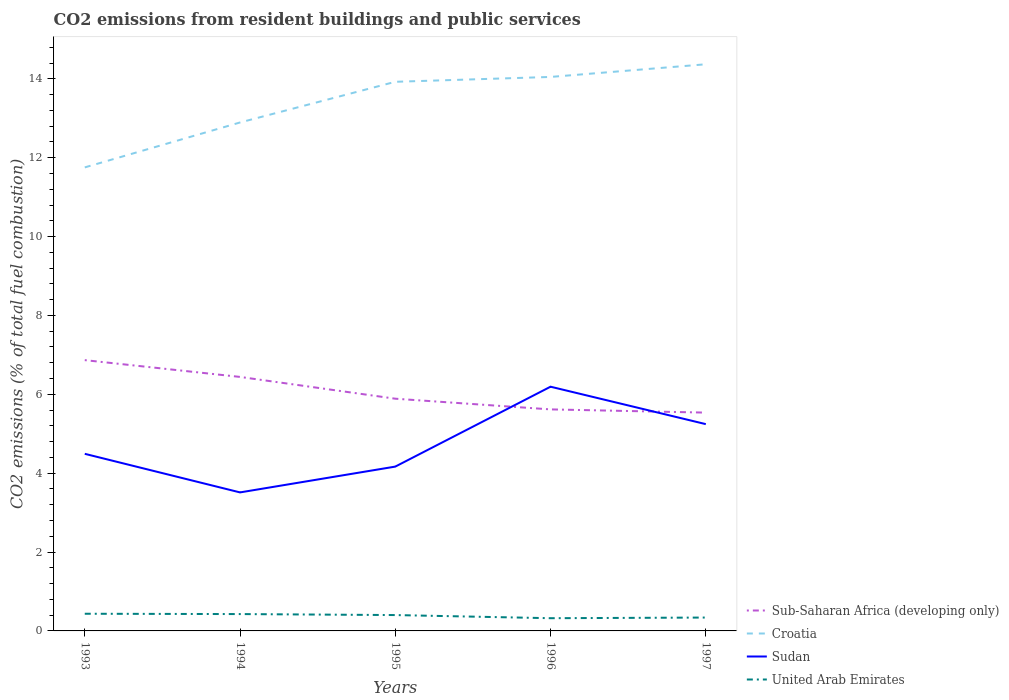How many different coloured lines are there?
Your answer should be compact. 4. Is the number of lines equal to the number of legend labels?
Provide a short and direct response. Yes. Across all years, what is the maximum total CO2 emitted in Sub-Saharan Africa (developing only)?
Ensure brevity in your answer.  5.54. What is the total total CO2 emitted in Sudan in the graph?
Make the answer very short. -0.75. What is the difference between the highest and the second highest total CO2 emitted in United Arab Emirates?
Keep it short and to the point. 0.11. How many lines are there?
Make the answer very short. 4. How many years are there in the graph?
Provide a succinct answer. 5. Are the values on the major ticks of Y-axis written in scientific E-notation?
Your response must be concise. No. Does the graph contain any zero values?
Your answer should be compact. No. Does the graph contain grids?
Offer a terse response. No. How many legend labels are there?
Your answer should be compact. 4. What is the title of the graph?
Provide a short and direct response. CO2 emissions from resident buildings and public services. What is the label or title of the Y-axis?
Offer a terse response. CO2 emissions (% of total fuel combustion). What is the CO2 emissions (% of total fuel combustion) of Sub-Saharan Africa (developing only) in 1993?
Provide a succinct answer. 6.87. What is the CO2 emissions (% of total fuel combustion) in Croatia in 1993?
Offer a very short reply. 11.75. What is the CO2 emissions (% of total fuel combustion) of Sudan in 1993?
Give a very brief answer. 4.49. What is the CO2 emissions (% of total fuel combustion) in United Arab Emirates in 1993?
Your answer should be very brief. 0.44. What is the CO2 emissions (% of total fuel combustion) in Sub-Saharan Africa (developing only) in 1994?
Provide a succinct answer. 6.44. What is the CO2 emissions (% of total fuel combustion) of Croatia in 1994?
Provide a short and direct response. 12.89. What is the CO2 emissions (% of total fuel combustion) in Sudan in 1994?
Offer a very short reply. 3.51. What is the CO2 emissions (% of total fuel combustion) in United Arab Emirates in 1994?
Offer a very short reply. 0.43. What is the CO2 emissions (% of total fuel combustion) in Sub-Saharan Africa (developing only) in 1995?
Your answer should be compact. 5.89. What is the CO2 emissions (% of total fuel combustion) in Croatia in 1995?
Your answer should be compact. 13.92. What is the CO2 emissions (% of total fuel combustion) of Sudan in 1995?
Provide a short and direct response. 4.17. What is the CO2 emissions (% of total fuel combustion) of United Arab Emirates in 1995?
Your answer should be very brief. 0.4. What is the CO2 emissions (% of total fuel combustion) in Sub-Saharan Africa (developing only) in 1996?
Your answer should be compact. 5.62. What is the CO2 emissions (% of total fuel combustion) of Croatia in 1996?
Give a very brief answer. 14.05. What is the CO2 emissions (% of total fuel combustion) of Sudan in 1996?
Your answer should be compact. 6.19. What is the CO2 emissions (% of total fuel combustion) of United Arab Emirates in 1996?
Keep it short and to the point. 0.32. What is the CO2 emissions (% of total fuel combustion) in Sub-Saharan Africa (developing only) in 1997?
Make the answer very short. 5.54. What is the CO2 emissions (% of total fuel combustion) of Croatia in 1997?
Ensure brevity in your answer.  14.37. What is the CO2 emissions (% of total fuel combustion) in Sudan in 1997?
Give a very brief answer. 5.24. What is the CO2 emissions (% of total fuel combustion) in United Arab Emirates in 1997?
Keep it short and to the point. 0.34. Across all years, what is the maximum CO2 emissions (% of total fuel combustion) of Sub-Saharan Africa (developing only)?
Ensure brevity in your answer.  6.87. Across all years, what is the maximum CO2 emissions (% of total fuel combustion) of Croatia?
Provide a succinct answer. 14.37. Across all years, what is the maximum CO2 emissions (% of total fuel combustion) in Sudan?
Ensure brevity in your answer.  6.19. Across all years, what is the maximum CO2 emissions (% of total fuel combustion) of United Arab Emirates?
Make the answer very short. 0.44. Across all years, what is the minimum CO2 emissions (% of total fuel combustion) in Sub-Saharan Africa (developing only)?
Provide a succinct answer. 5.54. Across all years, what is the minimum CO2 emissions (% of total fuel combustion) in Croatia?
Offer a very short reply. 11.75. Across all years, what is the minimum CO2 emissions (% of total fuel combustion) in Sudan?
Keep it short and to the point. 3.51. Across all years, what is the minimum CO2 emissions (% of total fuel combustion) in United Arab Emirates?
Keep it short and to the point. 0.32. What is the total CO2 emissions (% of total fuel combustion) in Sub-Saharan Africa (developing only) in the graph?
Provide a succinct answer. 30.35. What is the total CO2 emissions (% of total fuel combustion) of Croatia in the graph?
Offer a terse response. 66.99. What is the total CO2 emissions (% of total fuel combustion) of Sudan in the graph?
Provide a succinct answer. 23.61. What is the total CO2 emissions (% of total fuel combustion) of United Arab Emirates in the graph?
Your answer should be very brief. 1.93. What is the difference between the CO2 emissions (% of total fuel combustion) in Sub-Saharan Africa (developing only) in 1993 and that in 1994?
Your answer should be compact. 0.43. What is the difference between the CO2 emissions (% of total fuel combustion) of Croatia in 1993 and that in 1994?
Your answer should be very brief. -1.14. What is the difference between the CO2 emissions (% of total fuel combustion) in Sudan in 1993 and that in 1994?
Offer a terse response. 0.98. What is the difference between the CO2 emissions (% of total fuel combustion) in United Arab Emirates in 1993 and that in 1994?
Give a very brief answer. 0.01. What is the difference between the CO2 emissions (% of total fuel combustion) of Sub-Saharan Africa (developing only) in 1993 and that in 1995?
Provide a short and direct response. 0.98. What is the difference between the CO2 emissions (% of total fuel combustion) in Croatia in 1993 and that in 1995?
Ensure brevity in your answer.  -2.17. What is the difference between the CO2 emissions (% of total fuel combustion) in Sudan in 1993 and that in 1995?
Your response must be concise. 0.32. What is the difference between the CO2 emissions (% of total fuel combustion) of United Arab Emirates in 1993 and that in 1995?
Your response must be concise. 0.03. What is the difference between the CO2 emissions (% of total fuel combustion) in Sub-Saharan Africa (developing only) in 1993 and that in 1996?
Your response must be concise. 1.25. What is the difference between the CO2 emissions (% of total fuel combustion) in Croatia in 1993 and that in 1996?
Give a very brief answer. -2.29. What is the difference between the CO2 emissions (% of total fuel combustion) of Sudan in 1993 and that in 1996?
Your answer should be very brief. -1.7. What is the difference between the CO2 emissions (% of total fuel combustion) in United Arab Emirates in 1993 and that in 1996?
Make the answer very short. 0.11. What is the difference between the CO2 emissions (% of total fuel combustion) of Sub-Saharan Africa (developing only) in 1993 and that in 1997?
Make the answer very short. 1.33. What is the difference between the CO2 emissions (% of total fuel combustion) in Croatia in 1993 and that in 1997?
Provide a succinct answer. -2.62. What is the difference between the CO2 emissions (% of total fuel combustion) in Sudan in 1993 and that in 1997?
Give a very brief answer. -0.75. What is the difference between the CO2 emissions (% of total fuel combustion) in United Arab Emirates in 1993 and that in 1997?
Your answer should be very brief. 0.1. What is the difference between the CO2 emissions (% of total fuel combustion) in Sub-Saharan Africa (developing only) in 1994 and that in 1995?
Give a very brief answer. 0.55. What is the difference between the CO2 emissions (% of total fuel combustion) of Croatia in 1994 and that in 1995?
Give a very brief answer. -1.03. What is the difference between the CO2 emissions (% of total fuel combustion) in Sudan in 1994 and that in 1995?
Make the answer very short. -0.65. What is the difference between the CO2 emissions (% of total fuel combustion) in United Arab Emirates in 1994 and that in 1995?
Make the answer very short. 0.03. What is the difference between the CO2 emissions (% of total fuel combustion) of Sub-Saharan Africa (developing only) in 1994 and that in 1996?
Provide a succinct answer. 0.82. What is the difference between the CO2 emissions (% of total fuel combustion) of Croatia in 1994 and that in 1996?
Your answer should be very brief. -1.16. What is the difference between the CO2 emissions (% of total fuel combustion) in Sudan in 1994 and that in 1996?
Provide a short and direct response. -2.68. What is the difference between the CO2 emissions (% of total fuel combustion) of United Arab Emirates in 1994 and that in 1996?
Provide a succinct answer. 0.1. What is the difference between the CO2 emissions (% of total fuel combustion) in Sub-Saharan Africa (developing only) in 1994 and that in 1997?
Your answer should be compact. 0.91. What is the difference between the CO2 emissions (% of total fuel combustion) of Croatia in 1994 and that in 1997?
Your answer should be compact. -1.48. What is the difference between the CO2 emissions (% of total fuel combustion) in Sudan in 1994 and that in 1997?
Your response must be concise. -1.73. What is the difference between the CO2 emissions (% of total fuel combustion) in United Arab Emirates in 1994 and that in 1997?
Your answer should be very brief. 0.09. What is the difference between the CO2 emissions (% of total fuel combustion) in Sub-Saharan Africa (developing only) in 1995 and that in 1996?
Keep it short and to the point. 0.27. What is the difference between the CO2 emissions (% of total fuel combustion) of Croatia in 1995 and that in 1996?
Your answer should be very brief. -0.12. What is the difference between the CO2 emissions (% of total fuel combustion) in Sudan in 1995 and that in 1996?
Your response must be concise. -2.03. What is the difference between the CO2 emissions (% of total fuel combustion) in United Arab Emirates in 1995 and that in 1996?
Provide a short and direct response. 0.08. What is the difference between the CO2 emissions (% of total fuel combustion) in Sub-Saharan Africa (developing only) in 1995 and that in 1997?
Offer a terse response. 0.35. What is the difference between the CO2 emissions (% of total fuel combustion) in Croatia in 1995 and that in 1997?
Provide a short and direct response. -0.44. What is the difference between the CO2 emissions (% of total fuel combustion) of Sudan in 1995 and that in 1997?
Your answer should be compact. -1.08. What is the difference between the CO2 emissions (% of total fuel combustion) of United Arab Emirates in 1995 and that in 1997?
Your answer should be compact. 0.06. What is the difference between the CO2 emissions (% of total fuel combustion) of Sub-Saharan Africa (developing only) in 1996 and that in 1997?
Your response must be concise. 0.08. What is the difference between the CO2 emissions (% of total fuel combustion) in Croatia in 1996 and that in 1997?
Offer a terse response. -0.32. What is the difference between the CO2 emissions (% of total fuel combustion) of Sudan in 1996 and that in 1997?
Give a very brief answer. 0.95. What is the difference between the CO2 emissions (% of total fuel combustion) of United Arab Emirates in 1996 and that in 1997?
Give a very brief answer. -0.02. What is the difference between the CO2 emissions (% of total fuel combustion) in Sub-Saharan Africa (developing only) in 1993 and the CO2 emissions (% of total fuel combustion) in Croatia in 1994?
Provide a succinct answer. -6.03. What is the difference between the CO2 emissions (% of total fuel combustion) of Sub-Saharan Africa (developing only) in 1993 and the CO2 emissions (% of total fuel combustion) of Sudan in 1994?
Make the answer very short. 3.35. What is the difference between the CO2 emissions (% of total fuel combustion) in Sub-Saharan Africa (developing only) in 1993 and the CO2 emissions (% of total fuel combustion) in United Arab Emirates in 1994?
Ensure brevity in your answer.  6.44. What is the difference between the CO2 emissions (% of total fuel combustion) of Croatia in 1993 and the CO2 emissions (% of total fuel combustion) of Sudan in 1994?
Your answer should be very brief. 8.24. What is the difference between the CO2 emissions (% of total fuel combustion) of Croatia in 1993 and the CO2 emissions (% of total fuel combustion) of United Arab Emirates in 1994?
Provide a short and direct response. 11.33. What is the difference between the CO2 emissions (% of total fuel combustion) in Sudan in 1993 and the CO2 emissions (% of total fuel combustion) in United Arab Emirates in 1994?
Keep it short and to the point. 4.06. What is the difference between the CO2 emissions (% of total fuel combustion) in Sub-Saharan Africa (developing only) in 1993 and the CO2 emissions (% of total fuel combustion) in Croatia in 1995?
Give a very brief answer. -7.06. What is the difference between the CO2 emissions (% of total fuel combustion) in Sub-Saharan Africa (developing only) in 1993 and the CO2 emissions (% of total fuel combustion) in Sudan in 1995?
Offer a very short reply. 2.7. What is the difference between the CO2 emissions (% of total fuel combustion) in Sub-Saharan Africa (developing only) in 1993 and the CO2 emissions (% of total fuel combustion) in United Arab Emirates in 1995?
Make the answer very short. 6.46. What is the difference between the CO2 emissions (% of total fuel combustion) of Croatia in 1993 and the CO2 emissions (% of total fuel combustion) of Sudan in 1995?
Your response must be concise. 7.59. What is the difference between the CO2 emissions (% of total fuel combustion) in Croatia in 1993 and the CO2 emissions (% of total fuel combustion) in United Arab Emirates in 1995?
Offer a very short reply. 11.35. What is the difference between the CO2 emissions (% of total fuel combustion) of Sudan in 1993 and the CO2 emissions (% of total fuel combustion) of United Arab Emirates in 1995?
Offer a terse response. 4.09. What is the difference between the CO2 emissions (% of total fuel combustion) in Sub-Saharan Africa (developing only) in 1993 and the CO2 emissions (% of total fuel combustion) in Croatia in 1996?
Your response must be concise. -7.18. What is the difference between the CO2 emissions (% of total fuel combustion) in Sub-Saharan Africa (developing only) in 1993 and the CO2 emissions (% of total fuel combustion) in Sudan in 1996?
Keep it short and to the point. 0.67. What is the difference between the CO2 emissions (% of total fuel combustion) in Sub-Saharan Africa (developing only) in 1993 and the CO2 emissions (% of total fuel combustion) in United Arab Emirates in 1996?
Your answer should be very brief. 6.54. What is the difference between the CO2 emissions (% of total fuel combustion) of Croatia in 1993 and the CO2 emissions (% of total fuel combustion) of Sudan in 1996?
Your answer should be compact. 5.56. What is the difference between the CO2 emissions (% of total fuel combustion) in Croatia in 1993 and the CO2 emissions (% of total fuel combustion) in United Arab Emirates in 1996?
Provide a short and direct response. 11.43. What is the difference between the CO2 emissions (% of total fuel combustion) of Sudan in 1993 and the CO2 emissions (% of total fuel combustion) of United Arab Emirates in 1996?
Ensure brevity in your answer.  4.17. What is the difference between the CO2 emissions (% of total fuel combustion) in Sub-Saharan Africa (developing only) in 1993 and the CO2 emissions (% of total fuel combustion) in Croatia in 1997?
Provide a short and direct response. -7.5. What is the difference between the CO2 emissions (% of total fuel combustion) in Sub-Saharan Africa (developing only) in 1993 and the CO2 emissions (% of total fuel combustion) in Sudan in 1997?
Provide a short and direct response. 1.62. What is the difference between the CO2 emissions (% of total fuel combustion) of Sub-Saharan Africa (developing only) in 1993 and the CO2 emissions (% of total fuel combustion) of United Arab Emirates in 1997?
Your answer should be compact. 6.53. What is the difference between the CO2 emissions (% of total fuel combustion) of Croatia in 1993 and the CO2 emissions (% of total fuel combustion) of Sudan in 1997?
Provide a short and direct response. 6.51. What is the difference between the CO2 emissions (% of total fuel combustion) of Croatia in 1993 and the CO2 emissions (% of total fuel combustion) of United Arab Emirates in 1997?
Provide a succinct answer. 11.41. What is the difference between the CO2 emissions (% of total fuel combustion) in Sudan in 1993 and the CO2 emissions (% of total fuel combustion) in United Arab Emirates in 1997?
Your answer should be very brief. 4.15. What is the difference between the CO2 emissions (% of total fuel combustion) of Sub-Saharan Africa (developing only) in 1994 and the CO2 emissions (% of total fuel combustion) of Croatia in 1995?
Offer a very short reply. -7.48. What is the difference between the CO2 emissions (% of total fuel combustion) in Sub-Saharan Africa (developing only) in 1994 and the CO2 emissions (% of total fuel combustion) in Sudan in 1995?
Make the answer very short. 2.27. What is the difference between the CO2 emissions (% of total fuel combustion) in Sub-Saharan Africa (developing only) in 1994 and the CO2 emissions (% of total fuel combustion) in United Arab Emirates in 1995?
Offer a terse response. 6.04. What is the difference between the CO2 emissions (% of total fuel combustion) of Croatia in 1994 and the CO2 emissions (% of total fuel combustion) of Sudan in 1995?
Make the answer very short. 8.73. What is the difference between the CO2 emissions (% of total fuel combustion) in Croatia in 1994 and the CO2 emissions (% of total fuel combustion) in United Arab Emirates in 1995?
Your answer should be compact. 12.49. What is the difference between the CO2 emissions (% of total fuel combustion) of Sudan in 1994 and the CO2 emissions (% of total fuel combustion) of United Arab Emirates in 1995?
Provide a short and direct response. 3.11. What is the difference between the CO2 emissions (% of total fuel combustion) of Sub-Saharan Africa (developing only) in 1994 and the CO2 emissions (% of total fuel combustion) of Croatia in 1996?
Provide a short and direct response. -7.61. What is the difference between the CO2 emissions (% of total fuel combustion) in Sub-Saharan Africa (developing only) in 1994 and the CO2 emissions (% of total fuel combustion) in Sudan in 1996?
Provide a succinct answer. 0.25. What is the difference between the CO2 emissions (% of total fuel combustion) in Sub-Saharan Africa (developing only) in 1994 and the CO2 emissions (% of total fuel combustion) in United Arab Emirates in 1996?
Your response must be concise. 6.12. What is the difference between the CO2 emissions (% of total fuel combustion) of Croatia in 1994 and the CO2 emissions (% of total fuel combustion) of Sudan in 1996?
Your response must be concise. 6.7. What is the difference between the CO2 emissions (% of total fuel combustion) in Croatia in 1994 and the CO2 emissions (% of total fuel combustion) in United Arab Emirates in 1996?
Provide a short and direct response. 12.57. What is the difference between the CO2 emissions (% of total fuel combustion) in Sudan in 1994 and the CO2 emissions (% of total fuel combustion) in United Arab Emirates in 1996?
Ensure brevity in your answer.  3.19. What is the difference between the CO2 emissions (% of total fuel combustion) in Sub-Saharan Africa (developing only) in 1994 and the CO2 emissions (% of total fuel combustion) in Croatia in 1997?
Your response must be concise. -7.93. What is the difference between the CO2 emissions (% of total fuel combustion) of Sub-Saharan Africa (developing only) in 1994 and the CO2 emissions (% of total fuel combustion) of Sudan in 1997?
Your response must be concise. 1.2. What is the difference between the CO2 emissions (% of total fuel combustion) of Sub-Saharan Africa (developing only) in 1994 and the CO2 emissions (% of total fuel combustion) of United Arab Emirates in 1997?
Your response must be concise. 6.1. What is the difference between the CO2 emissions (% of total fuel combustion) of Croatia in 1994 and the CO2 emissions (% of total fuel combustion) of Sudan in 1997?
Give a very brief answer. 7.65. What is the difference between the CO2 emissions (% of total fuel combustion) of Croatia in 1994 and the CO2 emissions (% of total fuel combustion) of United Arab Emirates in 1997?
Ensure brevity in your answer.  12.55. What is the difference between the CO2 emissions (% of total fuel combustion) of Sudan in 1994 and the CO2 emissions (% of total fuel combustion) of United Arab Emirates in 1997?
Provide a succinct answer. 3.17. What is the difference between the CO2 emissions (% of total fuel combustion) in Sub-Saharan Africa (developing only) in 1995 and the CO2 emissions (% of total fuel combustion) in Croatia in 1996?
Provide a short and direct response. -8.16. What is the difference between the CO2 emissions (% of total fuel combustion) of Sub-Saharan Africa (developing only) in 1995 and the CO2 emissions (% of total fuel combustion) of Sudan in 1996?
Keep it short and to the point. -0.3. What is the difference between the CO2 emissions (% of total fuel combustion) in Sub-Saharan Africa (developing only) in 1995 and the CO2 emissions (% of total fuel combustion) in United Arab Emirates in 1996?
Make the answer very short. 5.57. What is the difference between the CO2 emissions (% of total fuel combustion) of Croatia in 1995 and the CO2 emissions (% of total fuel combustion) of Sudan in 1996?
Provide a short and direct response. 7.73. What is the difference between the CO2 emissions (% of total fuel combustion) of Croatia in 1995 and the CO2 emissions (% of total fuel combustion) of United Arab Emirates in 1996?
Provide a succinct answer. 13.6. What is the difference between the CO2 emissions (% of total fuel combustion) in Sudan in 1995 and the CO2 emissions (% of total fuel combustion) in United Arab Emirates in 1996?
Your answer should be very brief. 3.84. What is the difference between the CO2 emissions (% of total fuel combustion) in Sub-Saharan Africa (developing only) in 1995 and the CO2 emissions (% of total fuel combustion) in Croatia in 1997?
Keep it short and to the point. -8.48. What is the difference between the CO2 emissions (% of total fuel combustion) of Sub-Saharan Africa (developing only) in 1995 and the CO2 emissions (% of total fuel combustion) of Sudan in 1997?
Your answer should be very brief. 0.65. What is the difference between the CO2 emissions (% of total fuel combustion) in Sub-Saharan Africa (developing only) in 1995 and the CO2 emissions (% of total fuel combustion) in United Arab Emirates in 1997?
Your response must be concise. 5.55. What is the difference between the CO2 emissions (% of total fuel combustion) in Croatia in 1995 and the CO2 emissions (% of total fuel combustion) in Sudan in 1997?
Make the answer very short. 8.68. What is the difference between the CO2 emissions (% of total fuel combustion) of Croatia in 1995 and the CO2 emissions (% of total fuel combustion) of United Arab Emirates in 1997?
Provide a succinct answer. 13.59. What is the difference between the CO2 emissions (% of total fuel combustion) of Sudan in 1995 and the CO2 emissions (% of total fuel combustion) of United Arab Emirates in 1997?
Your answer should be compact. 3.83. What is the difference between the CO2 emissions (% of total fuel combustion) in Sub-Saharan Africa (developing only) in 1996 and the CO2 emissions (% of total fuel combustion) in Croatia in 1997?
Give a very brief answer. -8.75. What is the difference between the CO2 emissions (% of total fuel combustion) in Sub-Saharan Africa (developing only) in 1996 and the CO2 emissions (% of total fuel combustion) in Sudan in 1997?
Your answer should be very brief. 0.37. What is the difference between the CO2 emissions (% of total fuel combustion) of Sub-Saharan Africa (developing only) in 1996 and the CO2 emissions (% of total fuel combustion) of United Arab Emirates in 1997?
Give a very brief answer. 5.28. What is the difference between the CO2 emissions (% of total fuel combustion) in Croatia in 1996 and the CO2 emissions (% of total fuel combustion) in Sudan in 1997?
Your answer should be compact. 8.8. What is the difference between the CO2 emissions (% of total fuel combustion) in Croatia in 1996 and the CO2 emissions (% of total fuel combustion) in United Arab Emirates in 1997?
Provide a succinct answer. 13.71. What is the difference between the CO2 emissions (% of total fuel combustion) in Sudan in 1996 and the CO2 emissions (% of total fuel combustion) in United Arab Emirates in 1997?
Ensure brevity in your answer.  5.85. What is the average CO2 emissions (% of total fuel combustion) of Sub-Saharan Africa (developing only) per year?
Provide a short and direct response. 6.07. What is the average CO2 emissions (% of total fuel combustion) in Croatia per year?
Provide a short and direct response. 13.4. What is the average CO2 emissions (% of total fuel combustion) of Sudan per year?
Provide a short and direct response. 4.72. What is the average CO2 emissions (% of total fuel combustion) of United Arab Emirates per year?
Your answer should be very brief. 0.39. In the year 1993, what is the difference between the CO2 emissions (% of total fuel combustion) in Sub-Saharan Africa (developing only) and CO2 emissions (% of total fuel combustion) in Croatia?
Make the answer very short. -4.89. In the year 1993, what is the difference between the CO2 emissions (% of total fuel combustion) of Sub-Saharan Africa (developing only) and CO2 emissions (% of total fuel combustion) of Sudan?
Provide a short and direct response. 2.38. In the year 1993, what is the difference between the CO2 emissions (% of total fuel combustion) in Sub-Saharan Africa (developing only) and CO2 emissions (% of total fuel combustion) in United Arab Emirates?
Your answer should be compact. 6.43. In the year 1993, what is the difference between the CO2 emissions (% of total fuel combustion) of Croatia and CO2 emissions (% of total fuel combustion) of Sudan?
Offer a very short reply. 7.26. In the year 1993, what is the difference between the CO2 emissions (% of total fuel combustion) in Croatia and CO2 emissions (% of total fuel combustion) in United Arab Emirates?
Offer a very short reply. 11.32. In the year 1993, what is the difference between the CO2 emissions (% of total fuel combustion) of Sudan and CO2 emissions (% of total fuel combustion) of United Arab Emirates?
Your answer should be compact. 4.06. In the year 1994, what is the difference between the CO2 emissions (% of total fuel combustion) of Sub-Saharan Africa (developing only) and CO2 emissions (% of total fuel combustion) of Croatia?
Offer a terse response. -6.45. In the year 1994, what is the difference between the CO2 emissions (% of total fuel combustion) in Sub-Saharan Africa (developing only) and CO2 emissions (% of total fuel combustion) in Sudan?
Make the answer very short. 2.93. In the year 1994, what is the difference between the CO2 emissions (% of total fuel combustion) of Sub-Saharan Africa (developing only) and CO2 emissions (% of total fuel combustion) of United Arab Emirates?
Offer a terse response. 6.01. In the year 1994, what is the difference between the CO2 emissions (% of total fuel combustion) in Croatia and CO2 emissions (% of total fuel combustion) in Sudan?
Provide a succinct answer. 9.38. In the year 1994, what is the difference between the CO2 emissions (% of total fuel combustion) of Croatia and CO2 emissions (% of total fuel combustion) of United Arab Emirates?
Your answer should be compact. 12.47. In the year 1994, what is the difference between the CO2 emissions (% of total fuel combustion) of Sudan and CO2 emissions (% of total fuel combustion) of United Arab Emirates?
Your answer should be very brief. 3.09. In the year 1995, what is the difference between the CO2 emissions (% of total fuel combustion) in Sub-Saharan Africa (developing only) and CO2 emissions (% of total fuel combustion) in Croatia?
Make the answer very short. -8.04. In the year 1995, what is the difference between the CO2 emissions (% of total fuel combustion) of Sub-Saharan Africa (developing only) and CO2 emissions (% of total fuel combustion) of Sudan?
Give a very brief answer. 1.72. In the year 1995, what is the difference between the CO2 emissions (% of total fuel combustion) in Sub-Saharan Africa (developing only) and CO2 emissions (% of total fuel combustion) in United Arab Emirates?
Your answer should be compact. 5.49. In the year 1995, what is the difference between the CO2 emissions (% of total fuel combustion) of Croatia and CO2 emissions (% of total fuel combustion) of Sudan?
Provide a short and direct response. 9.76. In the year 1995, what is the difference between the CO2 emissions (% of total fuel combustion) in Croatia and CO2 emissions (% of total fuel combustion) in United Arab Emirates?
Your answer should be compact. 13.52. In the year 1995, what is the difference between the CO2 emissions (% of total fuel combustion) in Sudan and CO2 emissions (% of total fuel combustion) in United Arab Emirates?
Offer a terse response. 3.76. In the year 1996, what is the difference between the CO2 emissions (% of total fuel combustion) in Sub-Saharan Africa (developing only) and CO2 emissions (% of total fuel combustion) in Croatia?
Give a very brief answer. -8.43. In the year 1996, what is the difference between the CO2 emissions (% of total fuel combustion) in Sub-Saharan Africa (developing only) and CO2 emissions (% of total fuel combustion) in Sudan?
Offer a very short reply. -0.58. In the year 1996, what is the difference between the CO2 emissions (% of total fuel combustion) of Sub-Saharan Africa (developing only) and CO2 emissions (% of total fuel combustion) of United Arab Emirates?
Provide a short and direct response. 5.29. In the year 1996, what is the difference between the CO2 emissions (% of total fuel combustion) in Croatia and CO2 emissions (% of total fuel combustion) in Sudan?
Ensure brevity in your answer.  7.85. In the year 1996, what is the difference between the CO2 emissions (% of total fuel combustion) in Croatia and CO2 emissions (% of total fuel combustion) in United Arab Emirates?
Provide a succinct answer. 13.72. In the year 1996, what is the difference between the CO2 emissions (% of total fuel combustion) in Sudan and CO2 emissions (% of total fuel combustion) in United Arab Emirates?
Make the answer very short. 5.87. In the year 1997, what is the difference between the CO2 emissions (% of total fuel combustion) of Sub-Saharan Africa (developing only) and CO2 emissions (% of total fuel combustion) of Croatia?
Keep it short and to the point. -8.83. In the year 1997, what is the difference between the CO2 emissions (% of total fuel combustion) in Sub-Saharan Africa (developing only) and CO2 emissions (% of total fuel combustion) in Sudan?
Give a very brief answer. 0.29. In the year 1997, what is the difference between the CO2 emissions (% of total fuel combustion) of Sub-Saharan Africa (developing only) and CO2 emissions (% of total fuel combustion) of United Arab Emirates?
Your answer should be very brief. 5.2. In the year 1997, what is the difference between the CO2 emissions (% of total fuel combustion) of Croatia and CO2 emissions (% of total fuel combustion) of Sudan?
Keep it short and to the point. 9.12. In the year 1997, what is the difference between the CO2 emissions (% of total fuel combustion) in Croatia and CO2 emissions (% of total fuel combustion) in United Arab Emirates?
Your answer should be very brief. 14.03. In the year 1997, what is the difference between the CO2 emissions (% of total fuel combustion) in Sudan and CO2 emissions (% of total fuel combustion) in United Arab Emirates?
Your response must be concise. 4.9. What is the ratio of the CO2 emissions (% of total fuel combustion) of Sub-Saharan Africa (developing only) in 1993 to that in 1994?
Provide a succinct answer. 1.07. What is the ratio of the CO2 emissions (% of total fuel combustion) in Croatia in 1993 to that in 1994?
Your answer should be compact. 0.91. What is the ratio of the CO2 emissions (% of total fuel combustion) of Sudan in 1993 to that in 1994?
Make the answer very short. 1.28. What is the ratio of the CO2 emissions (% of total fuel combustion) in United Arab Emirates in 1993 to that in 1994?
Make the answer very short. 1.02. What is the ratio of the CO2 emissions (% of total fuel combustion) in Sub-Saharan Africa (developing only) in 1993 to that in 1995?
Offer a very short reply. 1.17. What is the ratio of the CO2 emissions (% of total fuel combustion) of Croatia in 1993 to that in 1995?
Offer a terse response. 0.84. What is the ratio of the CO2 emissions (% of total fuel combustion) in Sudan in 1993 to that in 1995?
Offer a very short reply. 1.08. What is the ratio of the CO2 emissions (% of total fuel combustion) of United Arab Emirates in 1993 to that in 1995?
Your response must be concise. 1.08. What is the ratio of the CO2 emissions (% of total fuel combustion) in Sub-Saharan Africa (developing only) in 1993 to that in 1996?
Offer a terse response. 1.22. What is the ratio of the CO2 emissions (% of total fuel combustion) in Croatia in 1993 to that in 1996?
Ensure brevity in your answer.  0.84. What is the ratio of the CO2 emissions (% of total fuel combustion) of Sudan in 1993 to that in 1996?
Offer a very short reply. 0.73. What is the ratio of the CO2 emissions (% of total fuel combustion) of United Arab Emirates in 1993 to that in 1996?
Provide a succinct answer. 1.35. What is the ratio of the CO2 emissions (% of total fuel combustion) of Sub-Saharan Africa (developing only) in 1993 to that in 1997?
Your answer should be very brief. 1.24. What is the ratio of the CO2 emissions (% of total fuel combustion) of Croatia in 1993 to that in 1997?
Provide a succinct answer. 0.82. What is the ratio of the CO2 emissions (% of total fuel combustion) in Sudan in 1993 to that in 1997?
Make the answer very short. 0.86. What is the ratio of the CO2 emissions (% of total fuel combustion) of United Arab Emirates in 1993 to that in 1997?
Your response must be concise. 1.28. What is the ratio of the CO2 emissions (% of total fuel combustion) of Sub-Saharan Africa (developing only) in 1994 to that in 1995?
Provide a short and direct response. 1.09. What is the ratio of the CO2 emissions (% of total fuel combustion) in Croatia in 1994 to that in 1995?
Provide a short and direct response. 0.93. What is the ratio of the CO2 emissions (% of total fuel combustion) in Sudan in 1994 to that in 1995?
Offer a very short reply. 0.84. What is the ratio of the CO2 emissions (% of total fuel combustion) of United Arab Emirates in 1994 to that in 1995?
Your answer should be very brief. 1.06. What is the ratio of the CO2 emissions (% of total fuel combustion) of Sub-Saharan Africa (developing only) in 1994 to that in 1996?
Give a very brief answer. 1.15. What is the ratio of the CO2 emissions (% of total fuel combustion) in Croatia in 1994 to that in 1996?
Offer a terse response. 0.92. What is the ratio of the CO2 emissions (% of total fuel combustion) of Sudan in 1994 to that in 1996?
Make the answer very short. 0.57. What is the ratio of the CO2 emissions (% of total fuel combustion) in United Arab Emirates in 1994 to that in 1996?
Provide a short and direct response. 1.32. What is the ratio of the CO2 emissions (% of total fuel combustion) in Sub-Saharan Africa (developing only) in 1994 to that in 1997?
Offer a very short reply. 1.16. What is the ratio of the CO2 emissions (% of total fuel combustion) in Croatia in 1994 to that in 1997?
Offer a very short reply. 0.9. What is the ratio of the CO2 emissions (% of total fuel combustion) of Sudan in 1994 to that in 1997?
Provide a succinct answer. 0.67. What is the ratio of the CO2 emissions (% of total fuel combustion) in United Arab Emirates in 1994 to that in 1997?
Provide a short and direct response. 1.26. What is the ratio of the CO2 emissions (% of total fuel combustion) of Sub-Saharan Africa (developing only) in 1995 to that in 1996?
Your answer should be compact. 1.05. What is the ratio of the CO2 emissions (% of total fuel combustion) of Croatia in 1995 to that in 1996?
Ensure brevity in your answer.  0.99. What is the ratio of the CO2 emissions (% of total fuel combustion) in Sudan in 1995 to that in 1996?
Make the answer very short. 0.67. What is the ratio of the CO2 emissions (% of total fuel combustion) of United Arab Emirates in 1995 to that in 1996?
Your response must be concise. 1.25. What is the ratio of the CO2 emissions (% of total fuel combustion) of Sub-Saharan Africa (developing only) in 1995 to that in 1997?
Your answer should be compact. 1.06. What is the ratio of the CO2 emissions (% of total fuel combustion) in Croatia in 1995 to that in 1997?
Your answer should be compact. 0.97. What is the ratio of the CO2 emissions (% of total fuel combustion) of Sudan in 1995 to that in 1997?
Your answer should be very brief. 0.79. What is the ratio of the CO2 emissions (% of total fuel combustion) of United Arab Emirates in 1995 to that in 1997?
Keep it short and to the point. 1.19. What is the ratio of the CO2 emissions (% of total fuel combustion) of Sub-Saharan Africa (developing only) in 1996 to that in 1997?
Your answer should be very brief. 1.01. What is the ratio of the CO2 emissions (% of total fuel combustion) in Croatia in 1996 to that in 1997?
Your answer should be compact. 0.98. What is the ratio of the CO2 emissions (% of total fuel combustion) in Sudan in 1996 to that in 1997?
Your answer should be very brief. 1.18. What is the ratio of the CO2 emissions (% of total fuel combustion) in United Arab Emirates in 1996 to that in 1997?
Keep it short and to the point. 0.95. What is the difference between the highest and the second highest CO2 emissions (% of total fuel combustion) of Sub-Saharan Africa (developing only)?
Provide a succinct answer. 0.43. What is the difference between the highest and the second highest CO2 emissions (% of total fuel combustion) of Croatia?
Provide a succinct answer. 0.32. What is the difference between the highest and the second highest CO2 emissions (% of total fuel combustion) of Sudan?
Your answer should be compact. 0.95. What is the difference between the highest and the second highest CO2 emissions (% of total fuel combustion) in United Arab Emirates?
Provide a short and direct response. 0.01. What is the difference between the highest and the lowest CO2 emissions (% of total fuel combustion) of Sub-Saharan Africa (developing only)?
Provide a succinct answer. 1.33. What is the difference between the highest and the lowest CO2 emissions (% of total fuel combustion) in Croatia?
Your answer should be compact. 2.62. What is the difference between the highest and the lowest CO2 emissions (% of total fuel combustion) of Sudan?
Provide a short and direct response. 2.68. What is the difference between the highest and the lowest CO2 emissions (% of total fuel combustion) of United Arab Emirates?
Your response must be concise. 0.11. 